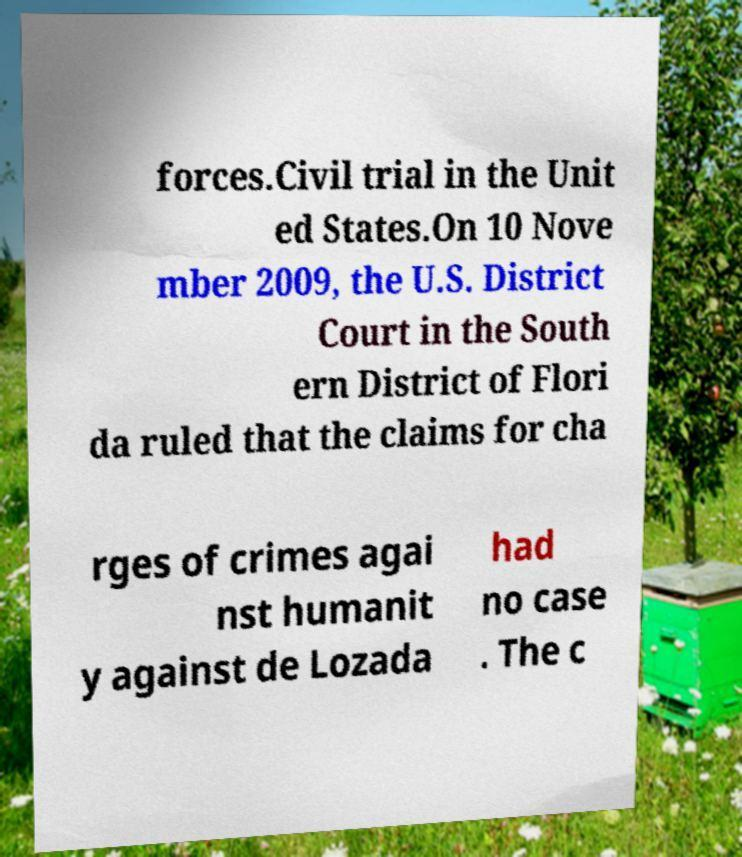Could you extract and type out the text from this image? forces.Civil trial in the Unit ed States.On 10 Nove mber 2009, the U.S. District Court in the South ern District of Flori da ruled that the claims for cha rges of crimes agai nst humanit y against de Lozada had no case . The c 